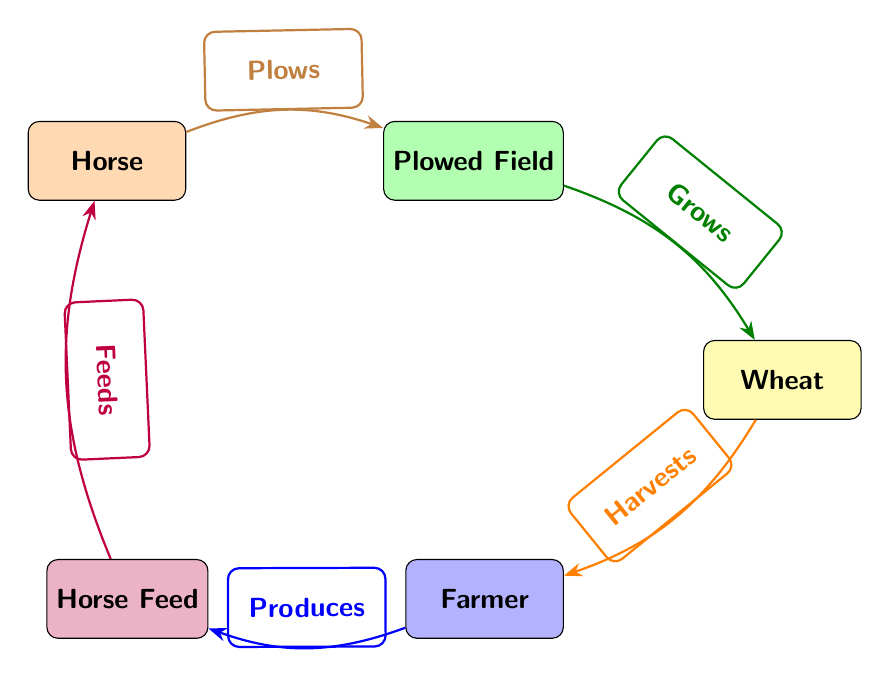What is the first node in the diagram? The first node in the diagram is labeled "Horse." This can be identified as it is positioned at the top of the depicted food chain.
Answer: Horse How many nodes are present in the diagram? The diagram contains five nodes: Horse, Plowed Field, Wheat, Farmer, and Horse Feed. Counting each one provides this total.
Answer: 5 Which node feeds the horse? The node that feeds the horse is labeled "Horse Feed." This can be determined as it is connected to the Horse with the label "Feeds."
Answer: Horse Feed What does the farmer produce? The farmer produces "Horse Feed." This is identified by following the connections from the Farmer node to the Horse Feed node, which is labeled "Produces."
Answer: Horse Feed What does the horse do to the plowed field? The horse "Plows" the plowed field. This is represented by the directed edge labeled "Plows" connecting the Horse node to the Plowed Field node.
Answer: Plows Which node is linked below the plowed field? The node linked below the Plowed Field is "Wheat." This can be observed as Wheat is positioned directly below it in the diagram.
Answer: Wheat What is the relationship between the wheat and the farmer? The relationship is that the farmer "Harvests" the wheat. This is indicated by the directed edge leading from the Wheat node to the Farmer node labeled "Harvests."
Answer: Harvests Which node grows the wheat? The node that grows the wheat is "Plowed Field." This link is established by the edge labeled "Grows" pointing from Plowed Field to Wheat.
Answer: Plowed Field What cycle does the horse's feed contribute to? The horse's feed contributes to the cycle where it "Feeds" the horse. This is represented by the edge labeled "Feeds" going back from Horse Feed to Horse.
Answer: Feeds 